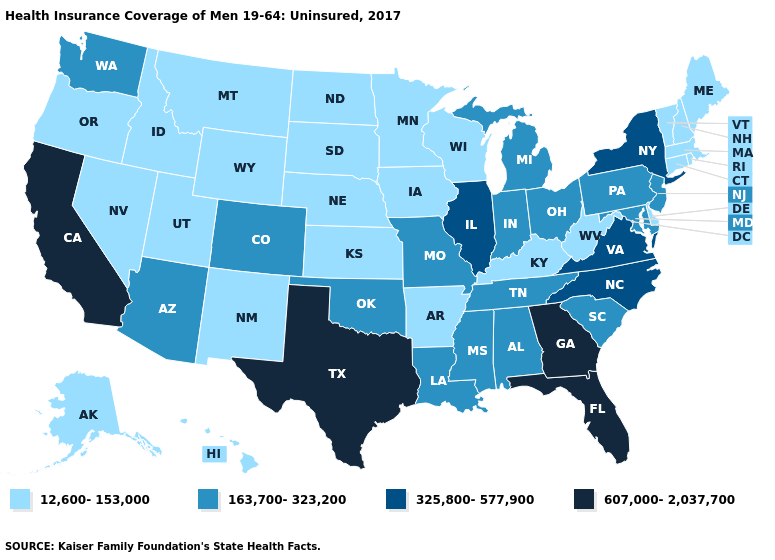What is the lowest value in the USA?
Be succinct. 12,600-153,000. What is the lowest value in the USA?
Give a very brief answer. 12,600-153,000. What is the highest value in the MidWest ?
Be succinct. 325,800-577,900. Among the states that border Maine , which have the highest value?
Keep it brief. New Hampshire. What is the value of Hawaii?
Answer briefly. 12,600-153,000. Does the map have missing data?
Give a very brief answer. No. What is the value of Rhode Island?
Be succinct. 12,600-153,000. What is the value of Minnesota?
Give a very brief answer. 12,600-153,000. Name the states that have a value in the range 12,600-153,000?
Answer briefly. Alaska, Arkansas, Connecticut, Delaware, Hawaii, Idaho, Iowa, Kansas, Kentucky, Maine, Massachusetts, Minnesota, Montana, Nebraska, Nevada, New Hampshire, New Mexico, North Dakota, Oregon, Rhode Island, South Dakota, Utah, Vermont, West Virginia, Wisconsin, Wyoming. Does Massachusetts have the same value as Washington?
Write a very short answer. No. Which states hav the highest value in the West?
Be succinct. California. Name the states that have a value in the range 12,600-153,000?
Answer briefly. Alaska, Arkansas, Connecticut, Delaware, Hawaii, Idaho, Iowa, Kansas, Kentucky, Maine, Massachusetts, Minnesota, Montana, Nebraska, Nevada, New Hampshire, New Mexico, North Dakota, Oregon, Rhode Island, South Dakota, Utah, Vermont, West Virginia, Wisconsin, Wyoming. What is the highest value in the USA?
Concise answer only. 607,000-2,037,700. Which states hav the highest value in the West?
Concise answer only. California. 